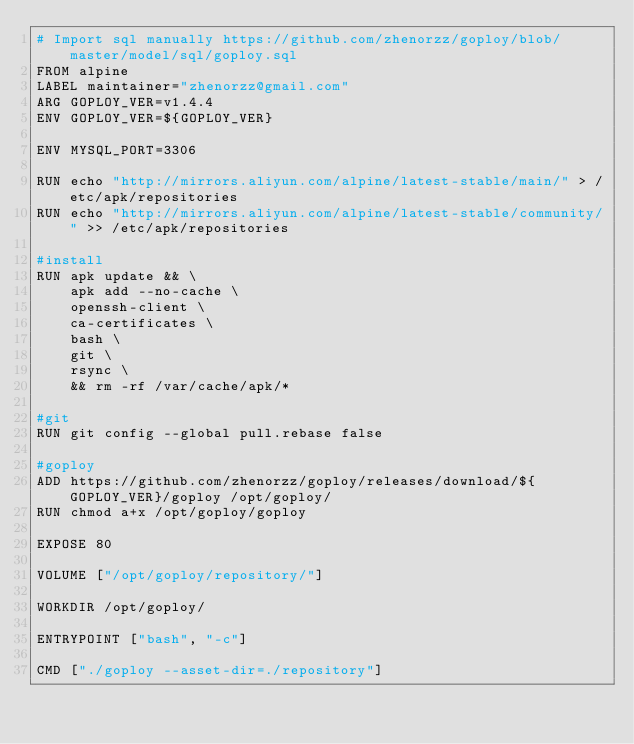<code> <loc_0><loc_0><loc_500><loc_500><_Dockerfile_># Import sql manually https://github.com/zhenorzz/goploy/blob/master/model/sql/goploy.sql
FROM alpine
LABEL maintainer="zhenorzz@gmail.com"
ARG GOPLOY_VER=v1.4.4
ENV GOPLOY_VER=${GOPLOY_VER}

ENV MYSQL_PORT=3306

RUN echo "http://mirrors.aliyun.com/alpine/latest-stable/main/" > /etc/apk/repositories
RUN echo "http://mirrors.aliyun.com/alpine/latest-stable/community/" >> /etc/apk/repositories

#install
RUN apk update && \
    apk add --no-cache \
    openssh-client \
    ca-certificates \
    bash \
    git \
    rsync \
    && rm -rf /var/cache/apk/* 

#git
RUN git config --global pull.rebase false

#goploy
ADD https://github.com/zhenorzz/goploy/releases/download/${GOPLOY_VER}/goploy /opt/goploy/
RUN chmod a+x /opt/goploy/goploy

EXPOSE 80

VOLUME ["/opt/goploy/repository/"]

WORKDIR /opt/goploy/

ENTRYPOINT ["bash", "-c"]

CMD ["./goploy --asset-dir=./repository"]
</code> 